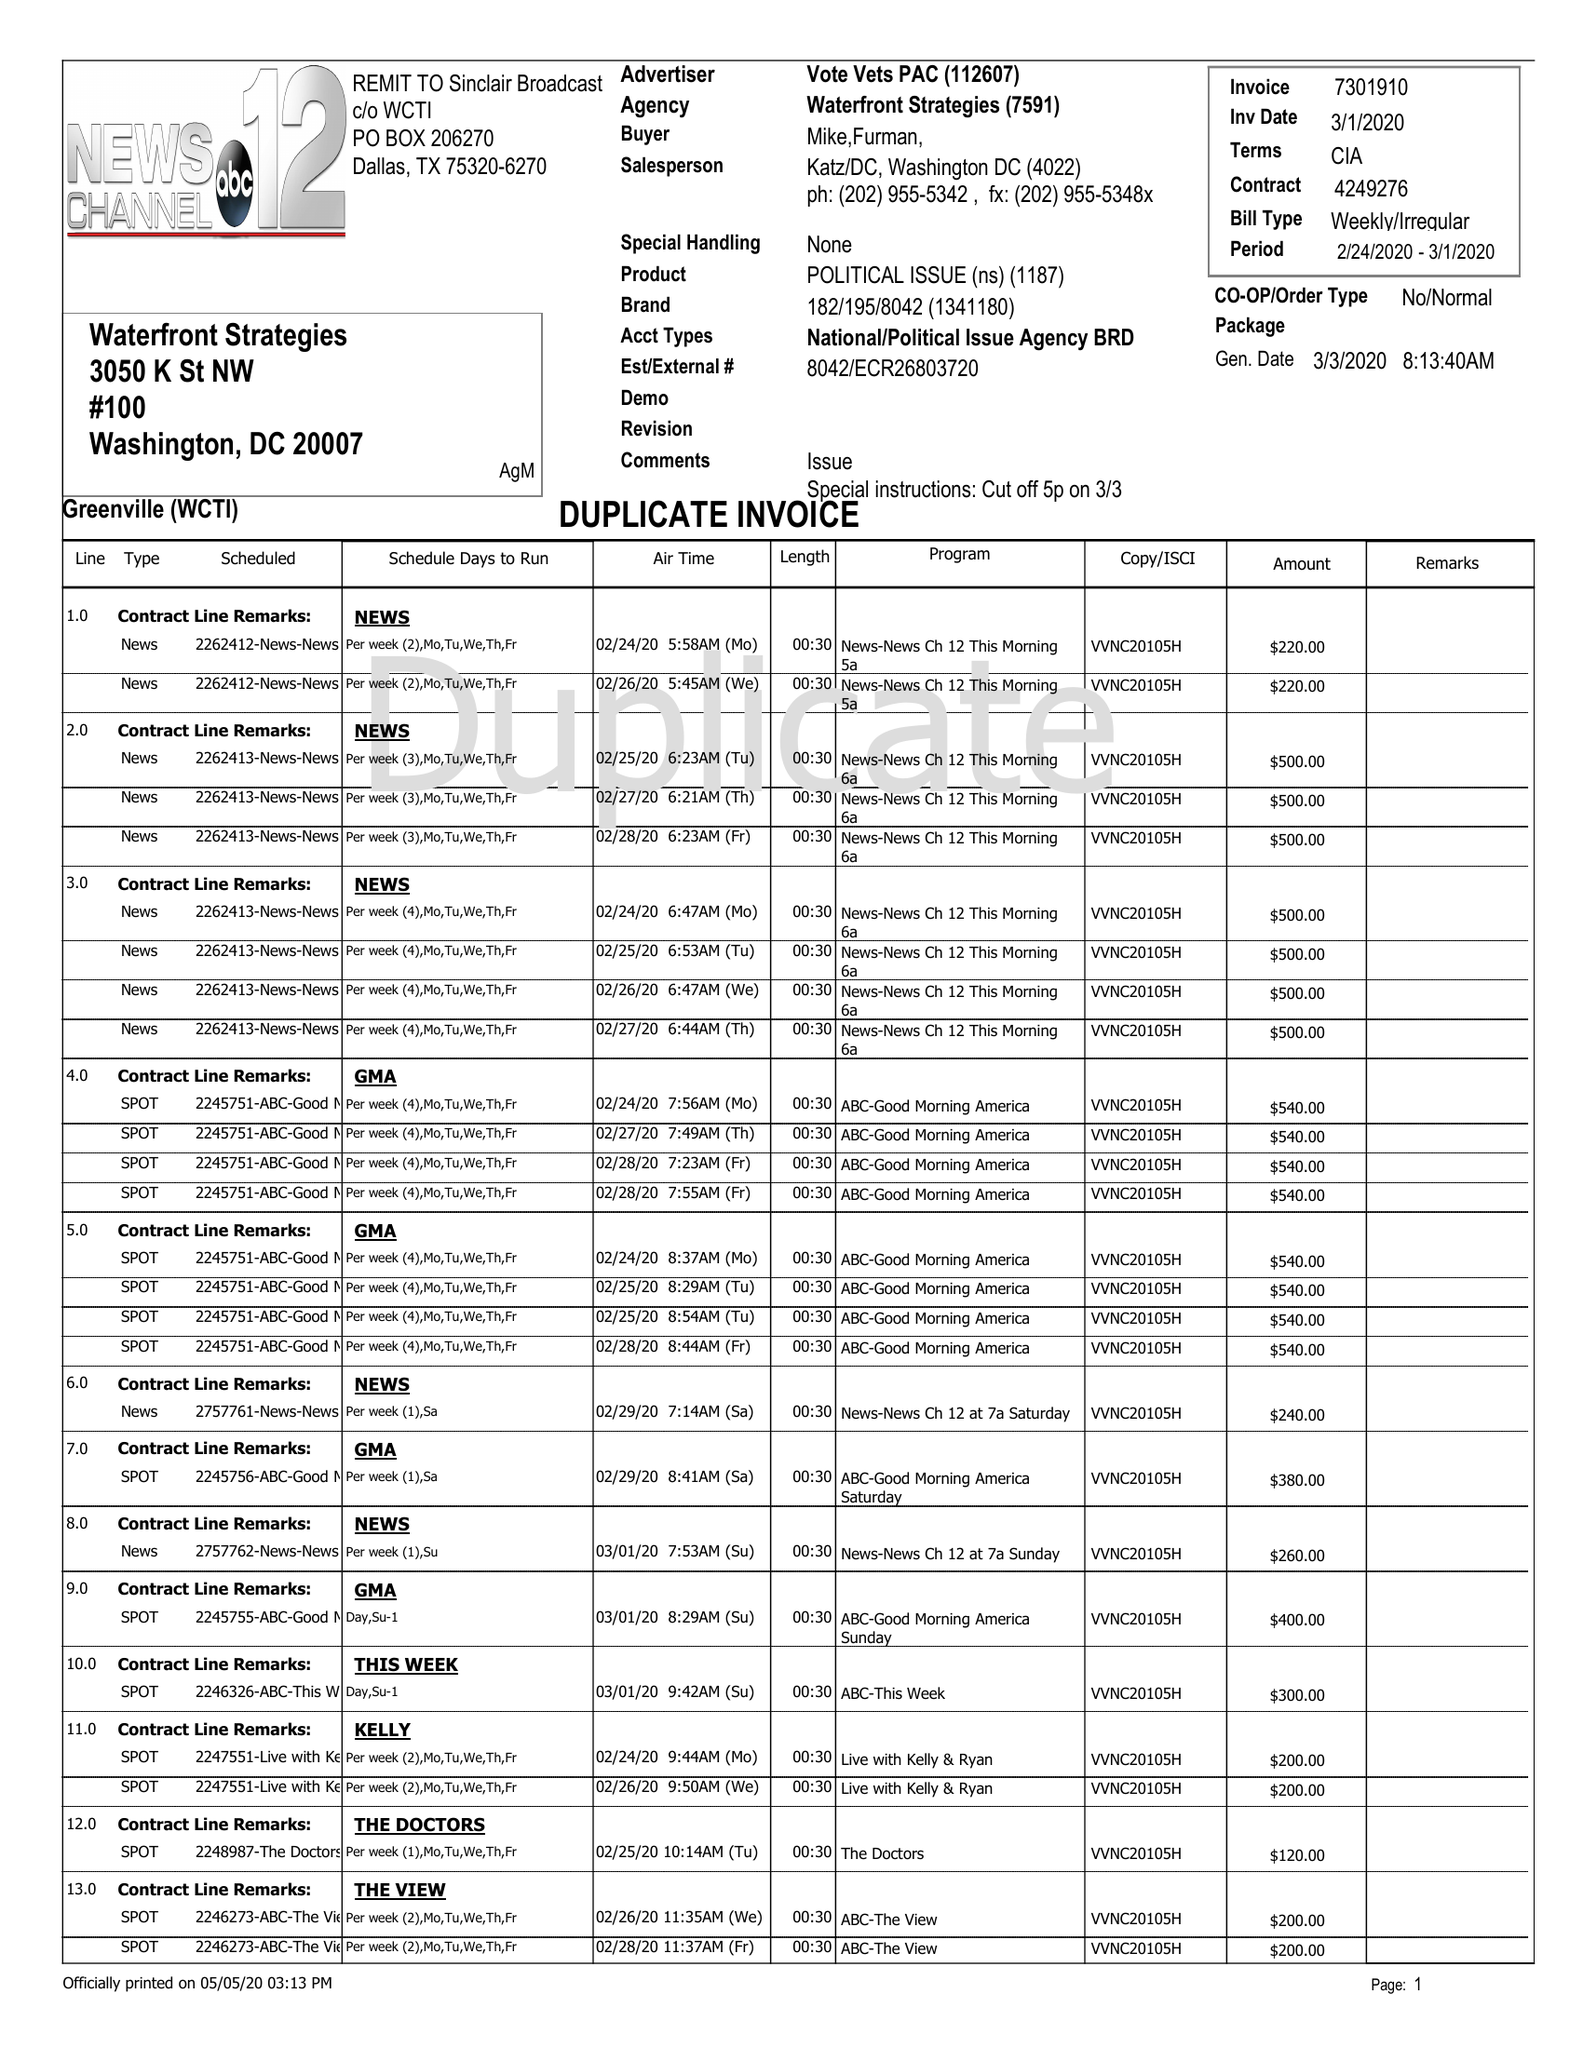What is the value for the gross_amount?
Answer the question using a single word or phrase. 41620.00 